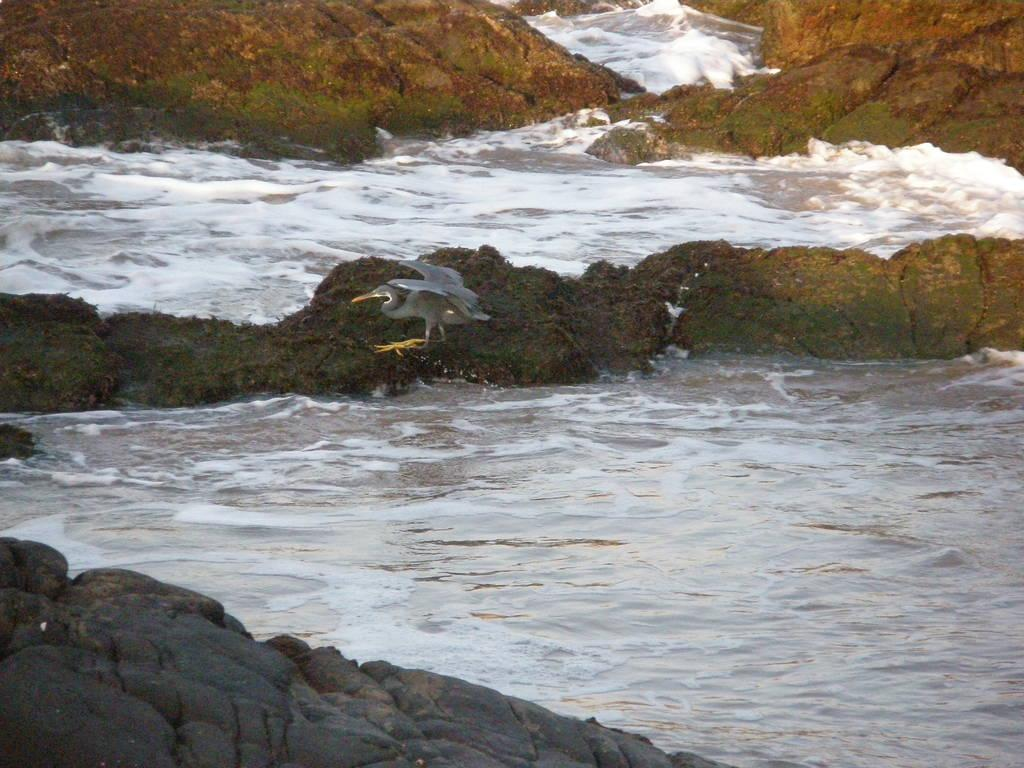What type of surface is visible in the image? There is a rock surface in the image. What can be seen behind the rock surface? There is water visible behind the rock surface. What is the color of the tides in the water behind the rock surface? The tides are white-colored in the water behind the rock surface. How many houses are visible in the image? There are no houses present in the image. What type of hall can be seen in the image? There is no hall present in the image. 